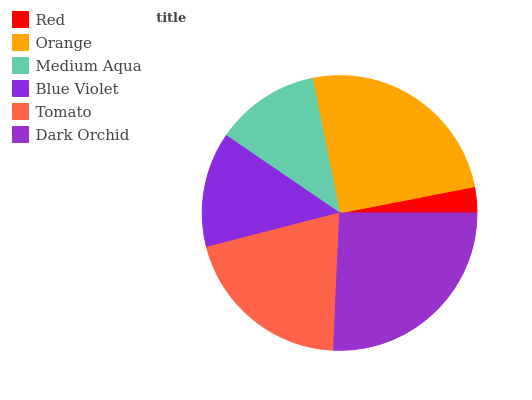Is Red the minimum?
Answer yes or no. Yes. Is Dark Orchid the maximum?
Answer yes or no. Yes. Is Orange the minimum?
Answer yes or no. No. Is Orange the maximum?
Answer yes or no. No. Is Orange greater than Red?
Answer yes or no. Yes. Is Red less than Orange?
Answer yes or no. Yes. Is Red greater than Orange?
Answer yes or no. No. Is Orange less than Red?
Answer yes or no. No. Is Tomato the high median?
Answer yes or no. Yes. Is Blue Violet the low median?
Answer yes or no. Yes. Is Blue Violet the high median?
Answer yes or no. No. Is Tomato the low median?
Answer yes or no. No. 